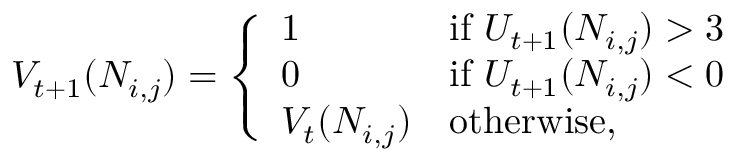Convert formula to latex. <formula><loc_0><loc_0><loc_500><loc_500>V _ { t + 1 } ( N _ { i , j } ) = \left \{ { \begin{array} { l l } { 1 } & { { i f } \, U _ { t + 1 } ( N _ { i , j } ) > 3 } \\ { 0 } & { { i f } \, U _ { t + 1 } ( N _ { i , j } ) < 0 } \\ { V _ { t } ( N _ { i , j } ) } & { { o t h e r w i s e } , } \end{array} }</formula> 